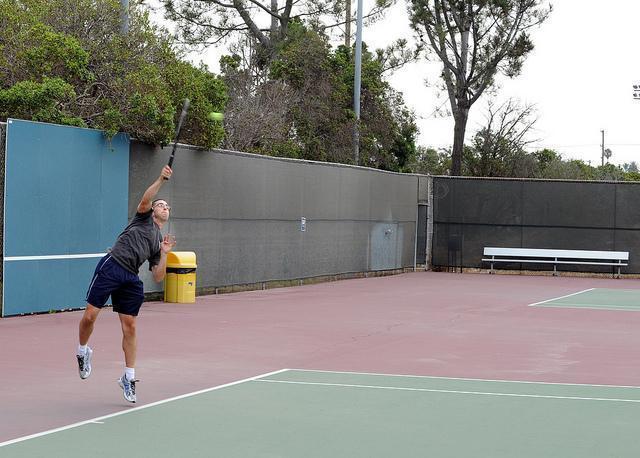Why is his arm raised so high?
From the following set of four choices, select the accurate answer to respond to the question.
Options: Is tired, hit ball, wants attention, is falling. Hit ball. 